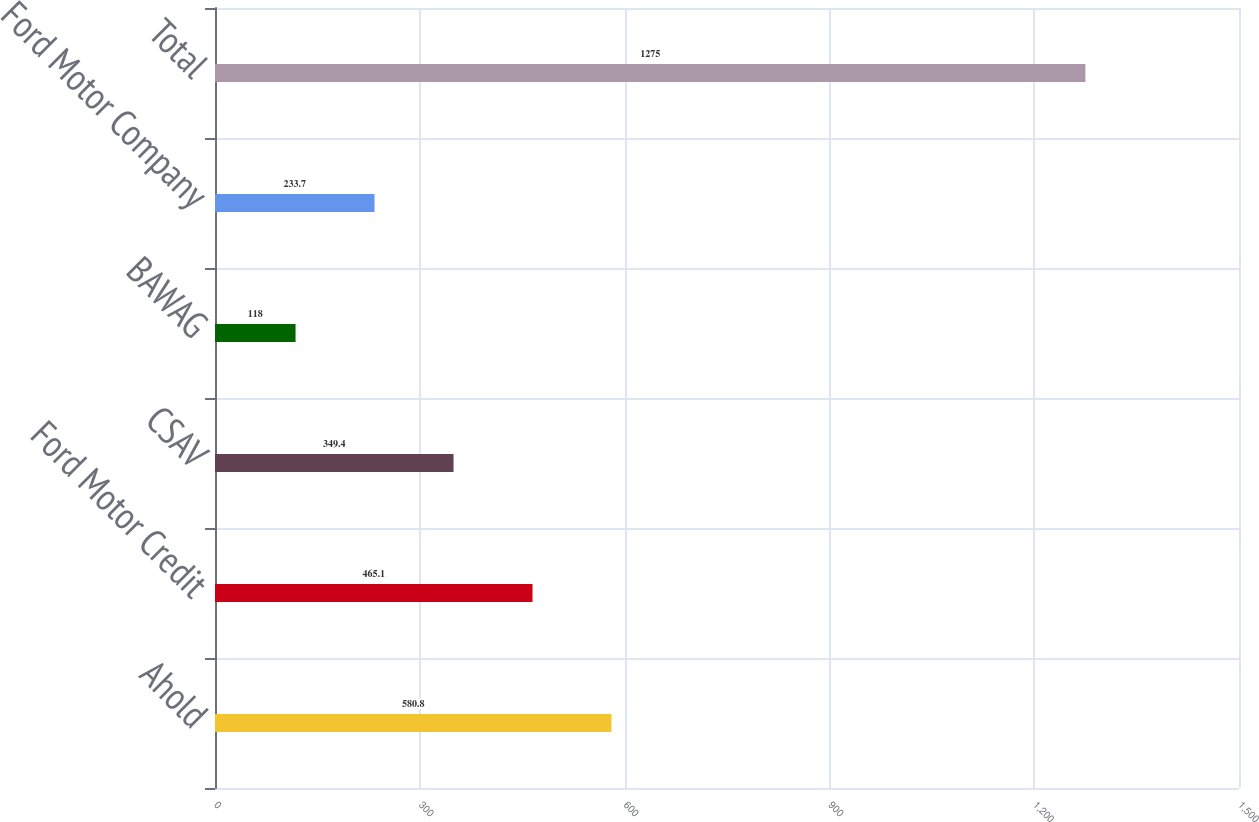<chart> <loc_0><loc_0><loc_500><loc_500><bar_chart><fcel>Ahold<fcel>Ford Motor Credit<fcel>CSAV<fcel>BAWAG<fcel>Ford Motor Company<fcel>Total<nl><fcel>580.8<fcel>465.1<fcel>349.4<fcel>118<fcel>233.7<fcel>1275<nl></chart> 